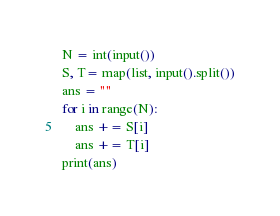<code> <loc_0><loc_0><loc_500><loc_500><_Python_>N = int(input())
S, T= map(list, input().split())
ans = ""
for i in range(N):
    ans += S[i]
    ans += T[i]
print(ans)</code> 